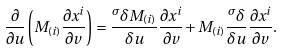<formula> <loc_0><loc_0><loc_500><loc_500>\frac { \partial } { \partial u } \left ( M _ { ( i ) } \frac { \partial x ^ { i } } { \partial v } \right ) = \frac { ^ { \sigma } \delta M _ { ( i ) } } { \delta u } \frac { \partial x ^ { i } } { \partial v } + M _ { ( i ) } \frac { ^ { \sigma } \delta } { \delta u } \frac { \partial x ^ { i } } { \partial v } .</formula> 